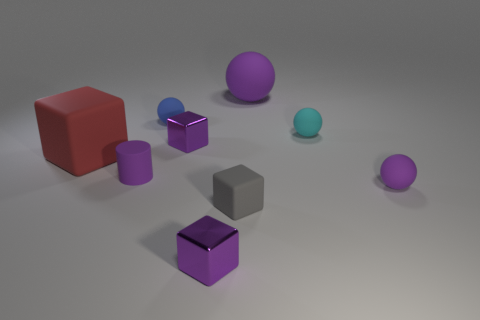What shape is the purple object that is both right of the small matte block and in front of the big purple rubber object?
Keep it short and to the point. Sphere. How many large purple rubber spheres are there?
Ensure brevity in your answer.  1. What is the material of the tiny purple object that is in front of the small purple matte thing to the right of the purple block that is in front of the large block?
Provide a short and direct response. Metal. There is a tiny object behind the small cyan rubber sphere; how many purple objects are to the left of it?
Provide a succinct answer. 1. What is the color of the other large rubber object that is the same shape as the blue rubber thing?
Ensure brevity in your answer.  Purple. What number of cylinders are either tiny rubber objects or small purple shiny objects?
Provide a succinct answer. 1. What is the size of the shiny thing that is behind the purple matte ball in front of the small purple object that is on the left side of the blue thing?
Your answer should be compact. Small. The gray matte thing that is the same shape as the red object is what size?
Your answer should be compact. Small. What number of large red objects are on the right side of the big purple ball?
Keep it short and to the point. 0. Is the color of the rubber object that is to the right of the cyan matte object the same as the tiny rubber cylinder?
Make the answer very short. Yes. 